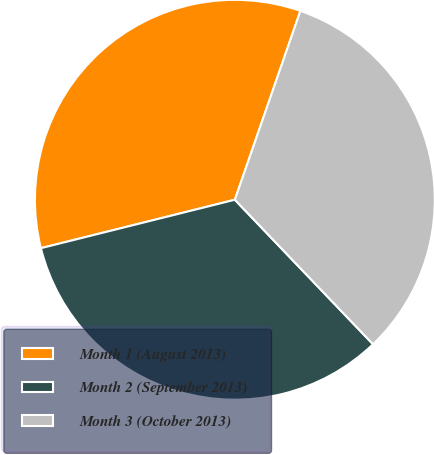<chart> <loc_0><loc_0><loc_500><loc_500><pie_chart><fcel>Month 1 (August 2013)<fcel>Month 2 (September 2013)<fcel>Month 3 (October 2013)<nl><fcel>34.21%<fcel>33.25%<fcel>32.54%<nl></chart> 